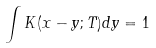Convert formula to latex. <formula><loc_0><loc_0><loc_500><loc_500>\int K ( x - y ; T ) d y = 1</formula> 